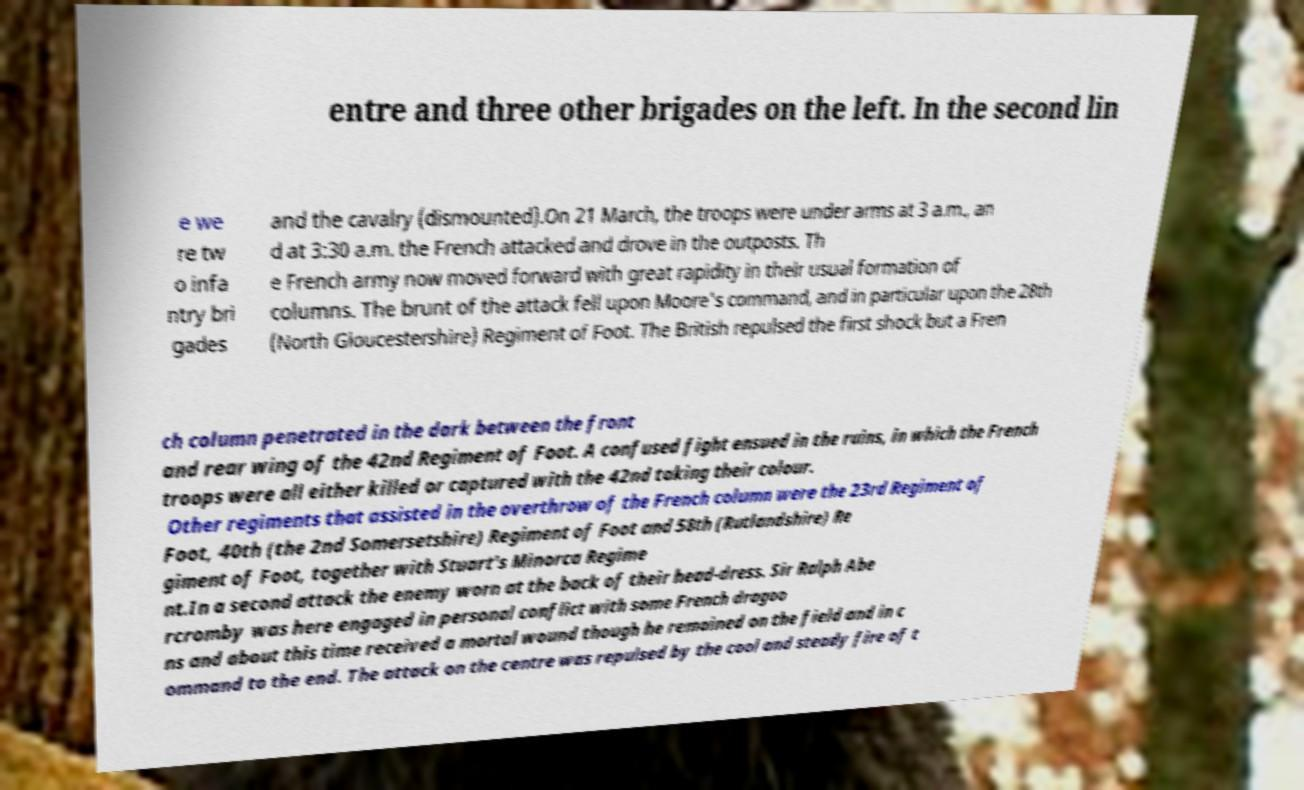Can you read and provide the text displayed in the image?This photo seems to have some interesting text. Can you extract and type it out for me? entre and three other brigades on the left. In the second lin e we re tw o infa ntry bri gades and the cavalry (dismounted).On 21 March, the troops were under arms at 3 a.m., an d at 3:30 a.m. the French attacked and drove in the outposts. Th e French army now moved forward with great rapidity in their usual formation of columns. The brunt of the attack fell upon Moore's command, and in particular upon the 28th (North Gloucestershire) Regiment of Foot. The British repulsed the first shock but a Fren ch column penetrated in the dark between the front and rear wing of the 42nd Regiment of Foot. A confused fight ensued in the ruins, in which the French troops were all either killed or captured with the 42nd taking their colour. Other regiments that assisted in the overthrow of the French column were the 23rd Regiment of Foot, 40th (the 2nd Somersetshire) Regiment of Foot and 58th (Rutlandshire) Re giment of Foot, together with Stuart's Minorca Regime nt.In a second attack the enemy worn at the back of their head-dress. Sir Ralph Abe rcromby was here engaged in personal conflict with some French dragoo ns and about this time received a mortal wound though he remained on the field and in c ommand to the end. The attack on the centre was repulsed by the cool and steady fire of t 